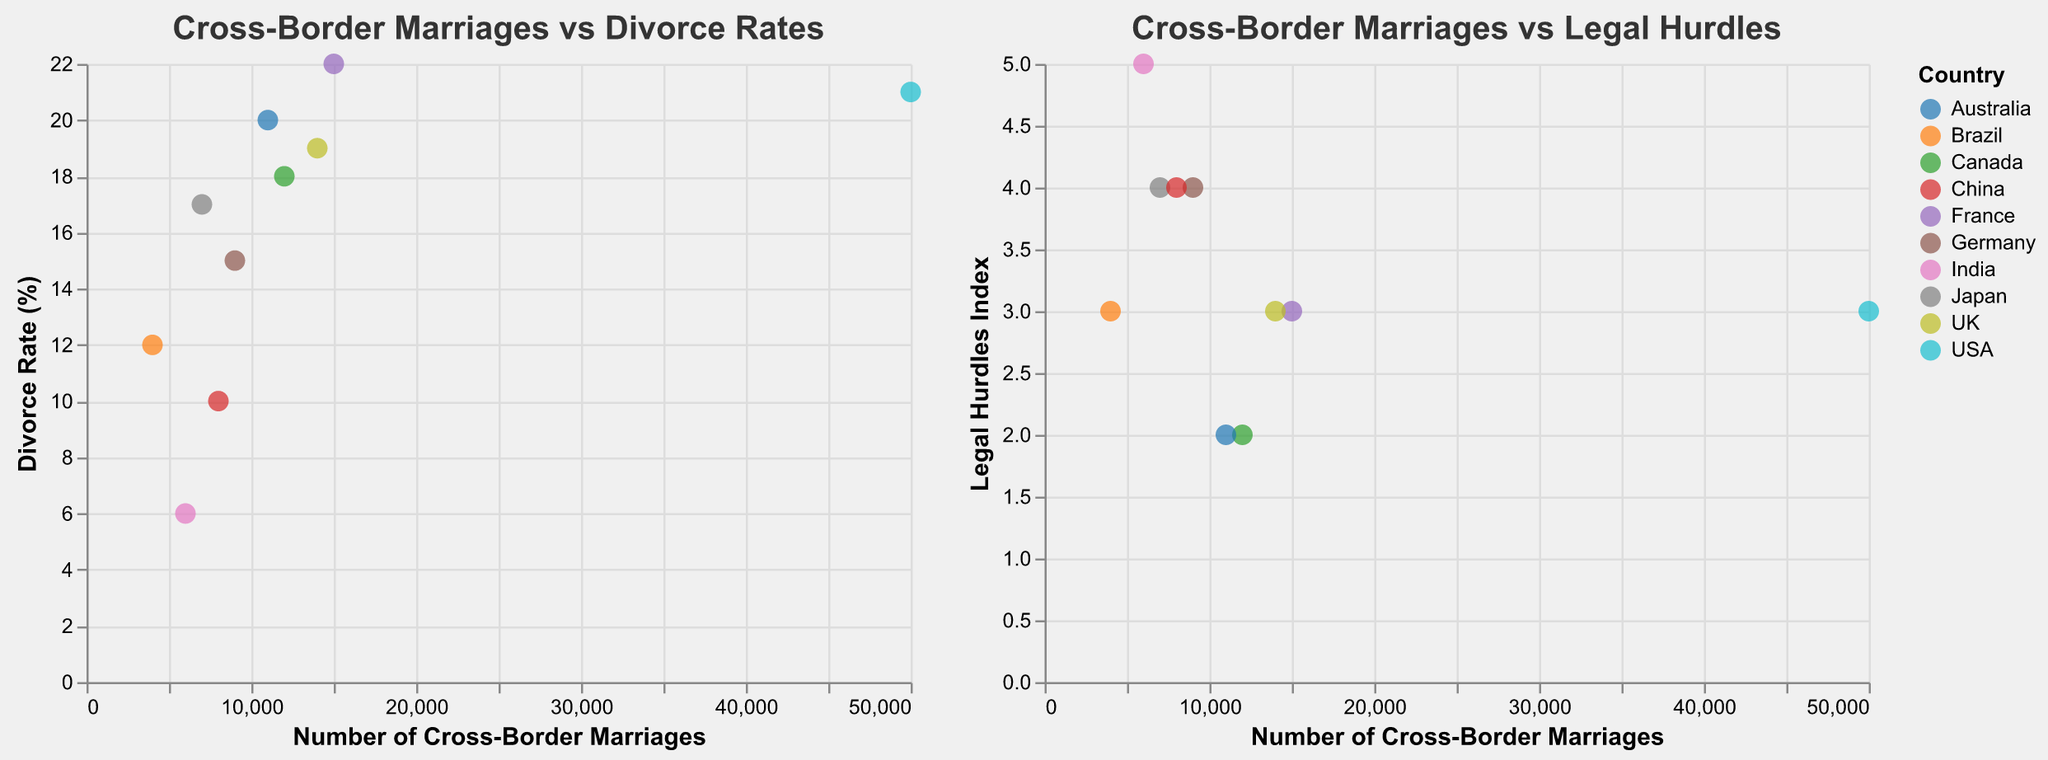How many countries are represented in the subplot? Count the number of unique countries listed in the scatter plots.
Answer: 10 Which country has the highest number of cross-border marriages? Look at the x-axis values and identify the country with the highest value.
Answer: USA What is the divorce rate in Germany? Find Germany in the scatter plot and note the corresponding value on the y-axis of the "Cross-Border Marriages vs Divorce Rates" subplot.
Answer: 15% Which two countries have the same Legal Hurdles Index, and what is the index value? Identify the countries with matching y-axis values in the "Cross-Border Marriages vs Legal Hurdles" subplot.
Answer: USA and France, 3 What is the average divorce rate across all countries? Sum all the divorce rate percentages and divide by the number of countries. \( (21 + 18 + 15 + 22 + 19 + 20 + 17 + 6 + 10 + 12) / 10 = 16 \)
Answer: 16% Which country has the lowest Legal Hurdles Index, and what is the associated number of cross-border marriages? Find the minimum y-axis value in the "Cross-Border Marriages vs Legal Hurdles" subplot and identify the corresponding country. Check its x-axis value.
Answer: Canada, 12000 Is there a positive correlation between the number of cross-border marriages and divorce rates? Observing the "Cross-Border Marriages vs Divorce Rates" subplot, check if higher marriage numbers correspond to higher divorce rates.
Answer: Yes Between Australia and Japan, which country has a higher divorce rate? Compare the y-axis values of Australia and Japan in the "Cross-Border Marriages vs Divorce Rates" subplot.
Answer: Australia What is the range of the Legal Hurdles Index in the countries plotted? Identify the minimum and maximum values of the y-axis in the "Cross-Border Marriages vs Legal Hurdles" subplot and determine their range.
Answer: 2 to 5 Which country has the highest cross-border marriages but the lowest divorce rate among all presented in the plot? Identify the country with the highest x-axis value and the lowest y-axis value in the "Cross-Border Marriages vs Divorce Rates" subplot, then check both conditions.
Answer: USA (highest marriages), India (lowest divorce rate) 